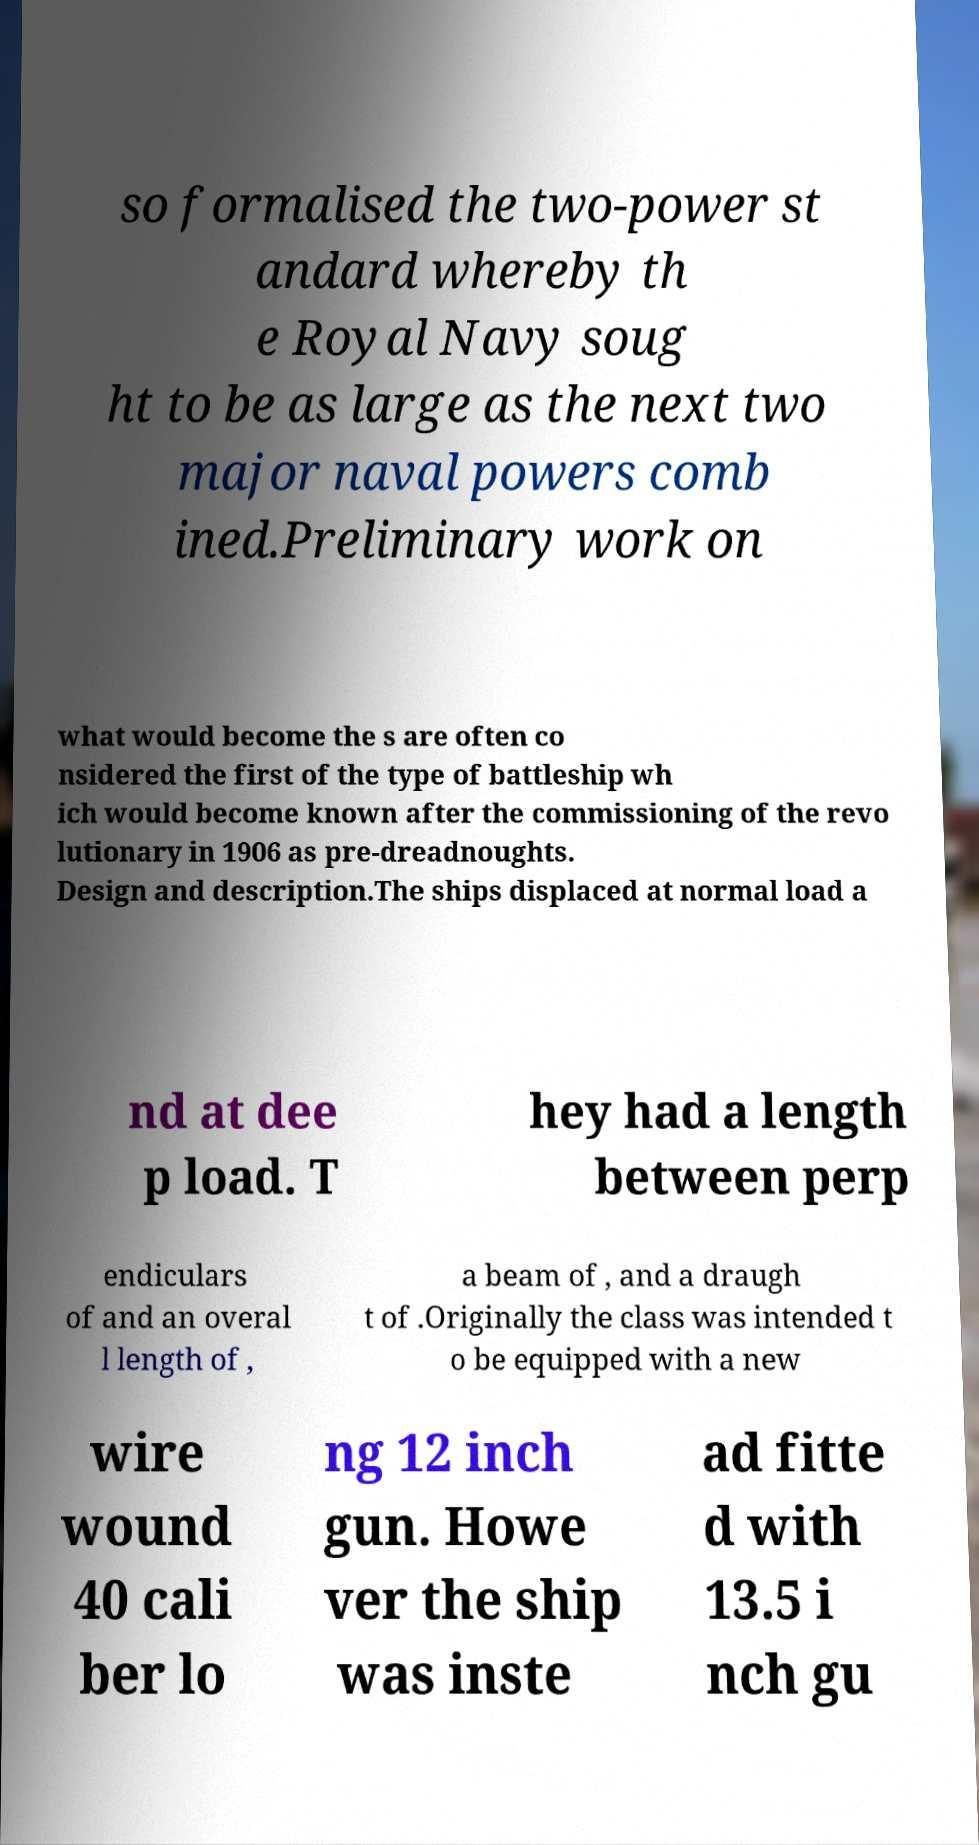What messages or text are displayed in this image? I need them in a readable, typed format. so formalised the two-power st andard whereby th e Royal Navy soug ht to be as large as the next two major naval powers comb ined.Preliminary work on what would become the s are often co nsidered the first of the type of battleship wh ich would become known after the commissioning of the revo lutionary in 1906 as pre-dreadnoughts. Design and description.The ships displaced at normal load a nd at dee p load. T hey had a length between perp endiculars of and an overal l length of , a beam of , and a draugh t of .Originally the class was intended t o be equipped with a new wire wound 40 cali ber lo ng 12 inch gun. Howe ver the ship was inste ad fitte d with 13.5 i nch gu 